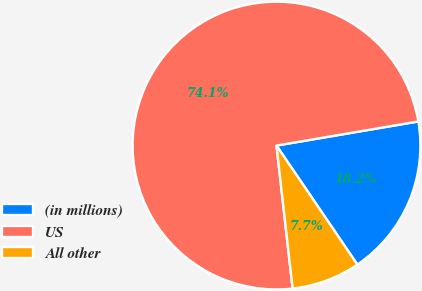Convert chart. <chart><loc_0><loc_0><loc_500><loc_500><pie_chart><fcel>(in millions)<fcel>US<fcel>All other<nl><fcel>18.18%<fcel>74.1%<fcel>7.71%<nl></chart> 